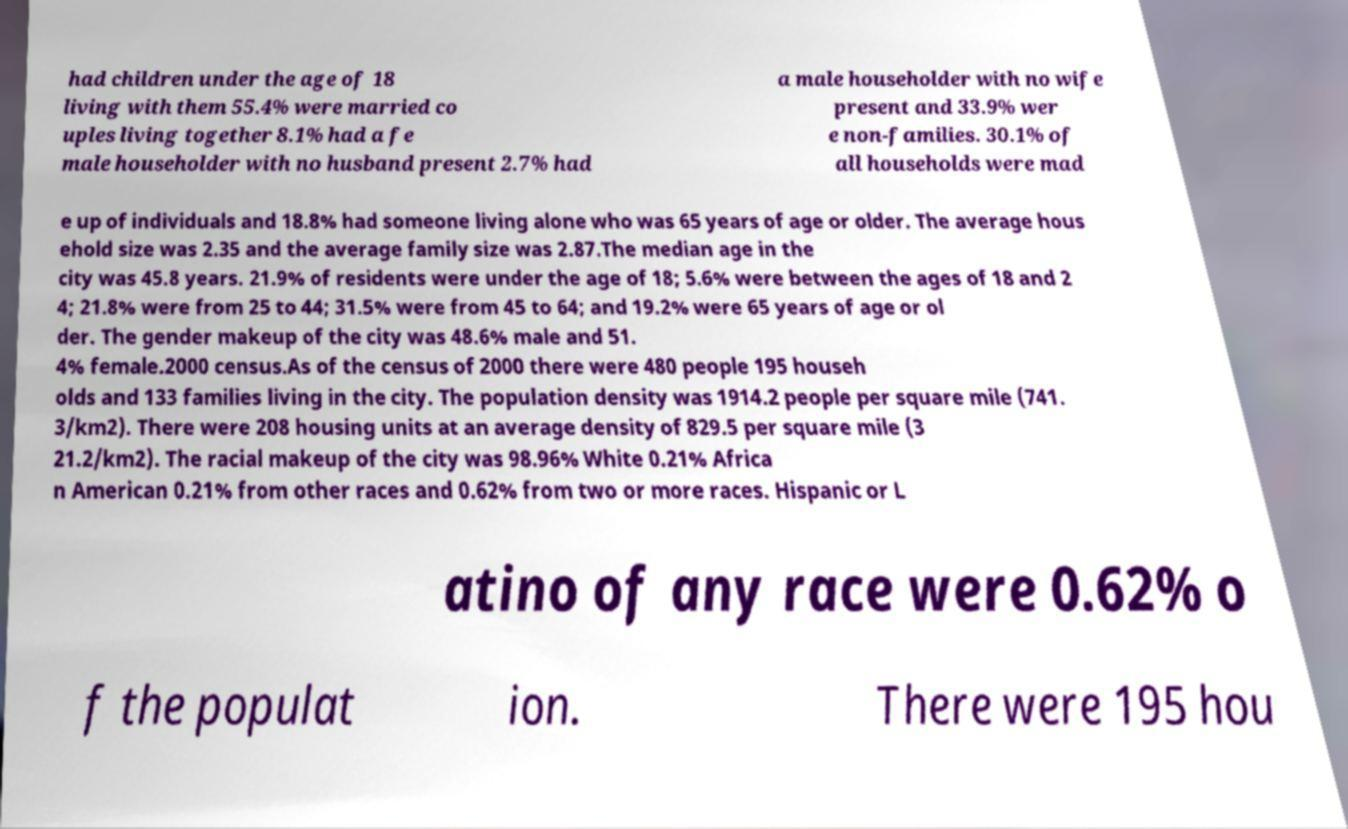Please identify and transcribe the text found in this image. had children under the age of 18 living with them 55.4% were married co uples living together 8.1% had a fe male householder with no husband present 2.7% had a male householder with no wife present and 33.9% wer e non-families. 30.1% of all households were mad e up of individuals and 18.8% had someone living alone who was 65 years of age or older. The average hous ehold size was 2.35 and the average family size was 2.87.The median age in the city was 45.8 years. 21.9% of residents were under the age of 18; 5.6% were between the ages of 18 and 2 4; 21.8% were from 25 to 44; 31.5% were from 45 to 64; and 19.2% were 65 years of age or ol der. The gender makeup of the city was 48.6% male and 51. 4% female.2000 census.As of the census of 2000 there were 480 people 195 househ olds and 133 families living in the city. The population density was 1914.2 people per square mile (741. 3/km2). There were 208 housing units at an average density of 829.5 per square mile (3 21.2/km2). The racial makeup of the city was 98.96% White 0.21% Africa n American 0.21% from other races and 0.62% from two or more races. Hispanic or L atino of any race were 0.62% o f the populat ion. There were 195 hou 